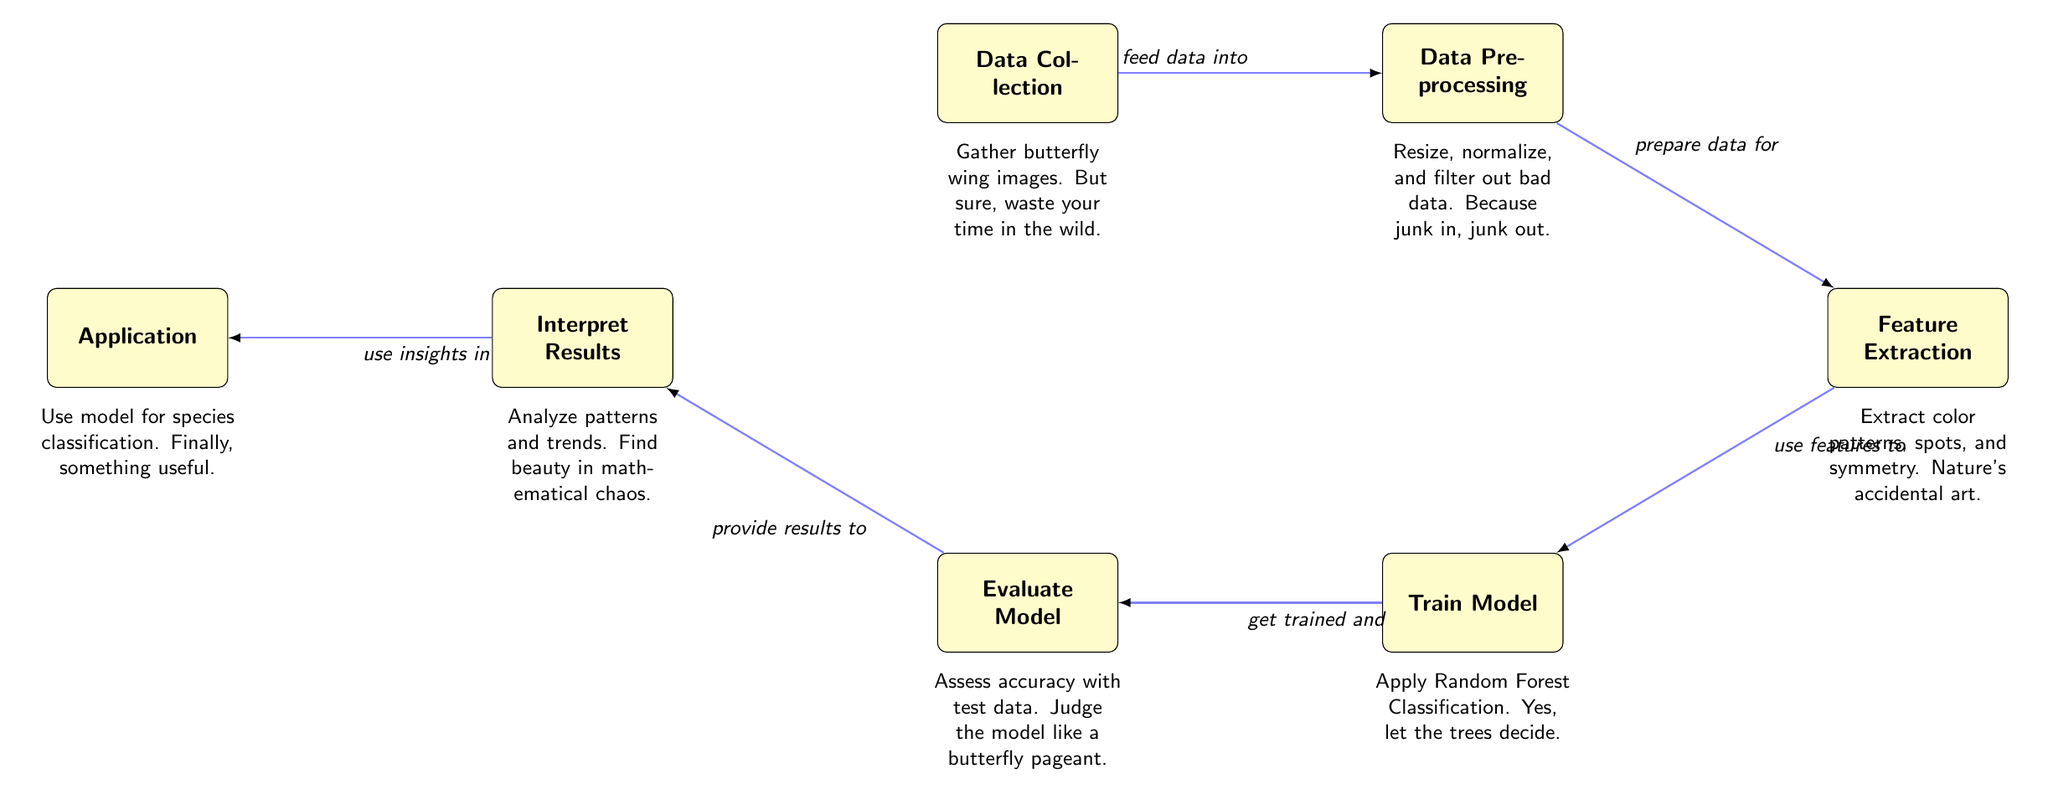What is the first node in the diagram? The first node in the diagram is "Data Collection." It is the starting point of the entire process, indicating the initial stage of gathering images of butterfly wings.
Answer: Data Collection How many nodes are present in the diagram? Counting the nodes present, there are a total of seven distinct nodes, each representing a different stage in the machine learning process.
Answer: Seven What is the relationship between "Data Preprocessing" and "Feature Extraction"? The relationship is that "Data Preprocessing" feeds data into "Feature Extraction." This shows that the prepared data is passed along for further analysis to extract relevant features.
Answer: Prepare data for What process is applied after "Feature Extraction"? After "Feature Extraction," the next step is "Train Model," indicating that the extracted features are then used to train the classification model.
Answer: Train Model Which node provides results to the "Interpret Results" node? The node that provides results to "Interpret Results" is "Evaluate Model." This shows that after model evaluation, the findings are then interpreted for further insights.
Answer: Evaluate Model What insights are gained from the "Interpret Results" node? The insights gained from the "Interpret Results" node involve analyzing patterns and trends, which leads to understanding the mathematical aspects of the data.
Answer: Analyze patterns and trends What is done with the model in the "Application" node? In the "Application" node, the trained model is used for species classification, demonstrating the practical application of the machine learning process.
Answer: Species classification What type of classification is used in this diagram? The type of classification used is "Random Forest Classification." This denotes the specific algorithm implemented in the training phase of the model.
Answer: Random Forest Classification What do we call the collected images of butterfly wings? The collected images are referred to as "Data," representing the raw input essential for the entire analysis process outlined in the diagram.
Answer: Data 